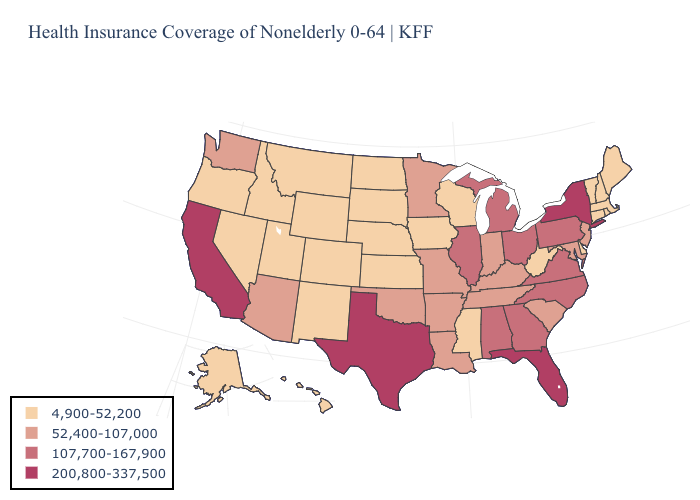Does the first symbol in the legend represent the smallest category?
Be succinct. Yes. What is the value of Hawaii?
Quick response, please. 4,900-52,200. What is the lowest value in states that border Delaware?
Quick response, please. 52,400-107,000. Name the states that have a value in the range 4,900-52,200?
Answer briefly. Alaska, Colorado, Connecticut, Delaware, Hawaii, Idaho, Iowa, Kansas, Maine, Massachusetts, Mississippi, Montana, Nebraska, Nevada, New Hampshire, New Mexico, North Dakota, Oregon, Rhode Island, South Dakota, Utah, Vermont, West Virginia, Wisconsin, Wyoming. Among the states that border Georgia , does Florida have the highest value?
Quick response, please. Yes. What is the lowest value in the USA?
Concise answer only. 4,900-52,200. Name the states that have a value in the range 52,400-107,000?
Write a very short answer. Arizona, Arkansas, Indiana, Kentucky, Louisiana, Maryland, Minnesota, Missouri, New Jersey, Oklahoma, South Carolina, Tennessee, Washington. Name the states that have a value in the range 200,800-337,500?
Quick response, please. California, Florida, New York, Texas. Among the states that border Tennessee , does Mississippi have the lowest value?
Quick response, please. Yes. Does the map have missing data?
Give a very brief answer. No. Does the map have missing data?
Short answer required. No. Does California have the highest value in the USA?
Be succinct. Yes. What is the value of Maine?
Quick response, please. 4,900-52,200. Name the states that have a value in the range 200,800-337,500?
Give a very brief answer. California, Florida, New York, Texas. Does the map have missing data?
Short answer required. No. 